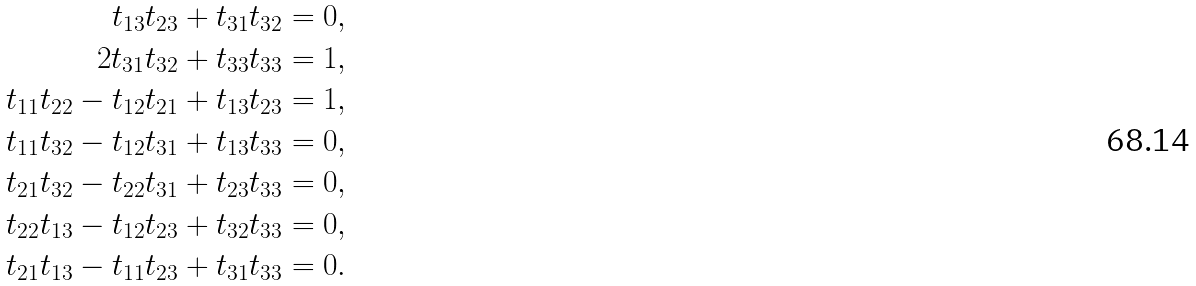<formula> <loc_0><loc_0><loc_500><loc_500>t _ { 1 3 } t _ { 2 3 } + t _ { 3 1 } t _ { 3 2 } = 0 , \\ 2 t _ { 3 1 } t _ { 3 2 } + t _ { 3 3 } t _ { 3 3 } = 1 , \\ t _ { 1 1 } t _ { 2 2 } - t _ { 1 2 } t _ { 2 1 } + t _ { 1 3 } t _ { 2 3 } = 1 , \\ t _ { 1 1 } t _ { 3 2 } - t _ { 1 2 } t _ { 3 1 } + t _ { 1 3 } t _ { 3 3 } = 0 , \\ t _ { 2 1 } t _ { 3 2 } - t _ { 2 2 } t _ { 3 1 } + t _ { 2 3 } t _ { 3 3 } = 0 , \\ t _ { 2 2 } t _ { 1 3 } - t _ { 1 2 } t _ { 2 3 } + t _ { 3 2 } t _ { 3 3 } = 0 , \\ t _ { 2 1 } t _ { 1 3 } - t _ { 1 1 } t _ { 2 3 } + t _ { 3 1 } t _ { 3 3 } = 0 .</formula> 